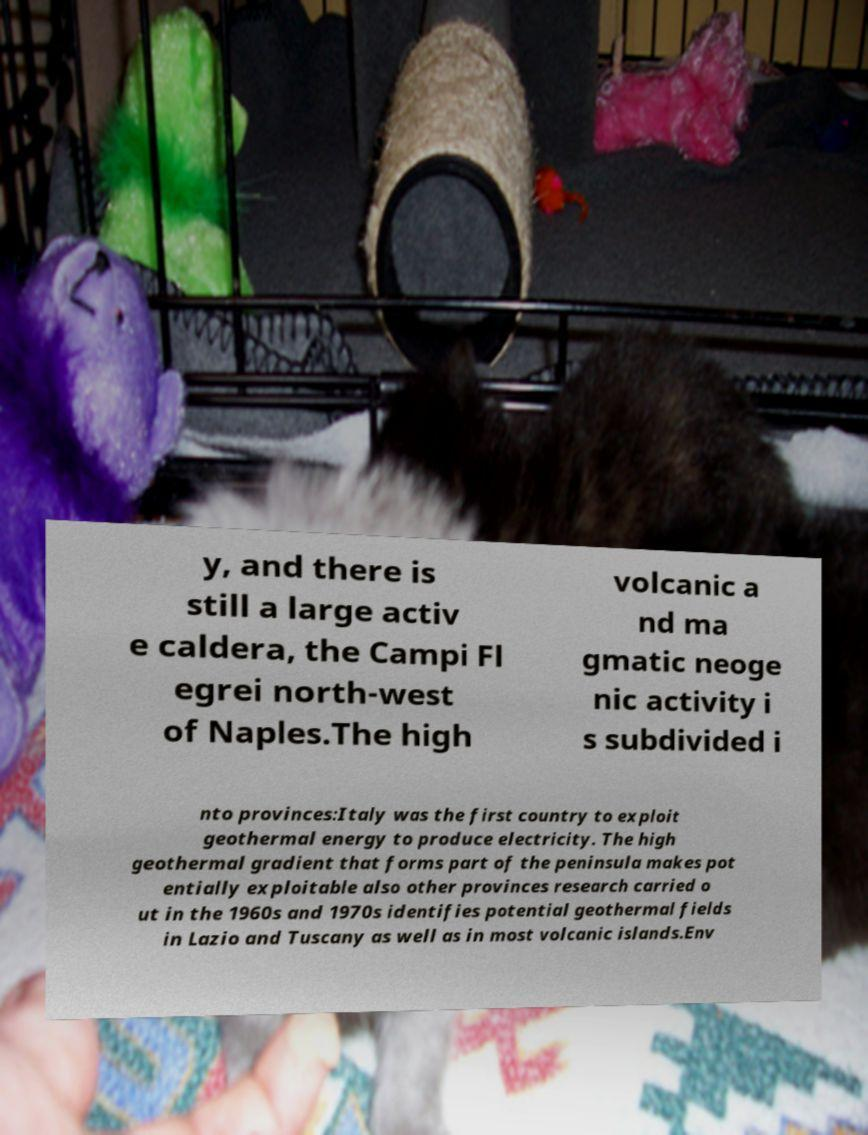I need the written content from this picture converted into text. Can you do that? y, and there is still a large activ e caldera, the Campi Fl egrei north-west of Naples.The high volcanic a nd ma gmatic neoge nic activity i s subdivided i nto provinces:Italy was the first country to exploit geothermal energy to produce electricity. The high geothermal gradient that forms part of the peninsula makes pot entially exploitable also other provinces research carried o ut in the 1960s and 1970s identifies potential geothermal fields in Lazio and Tuscany as well as in most volcanic islands.Env 